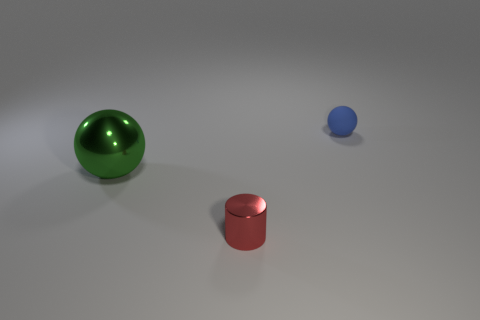Can you describe the lighting in the scene? The lighting in the scene is soft and ambient, with no harsh shadows, indicative of diffuse lighting often used in a studio setting to showcase objects clearly. 